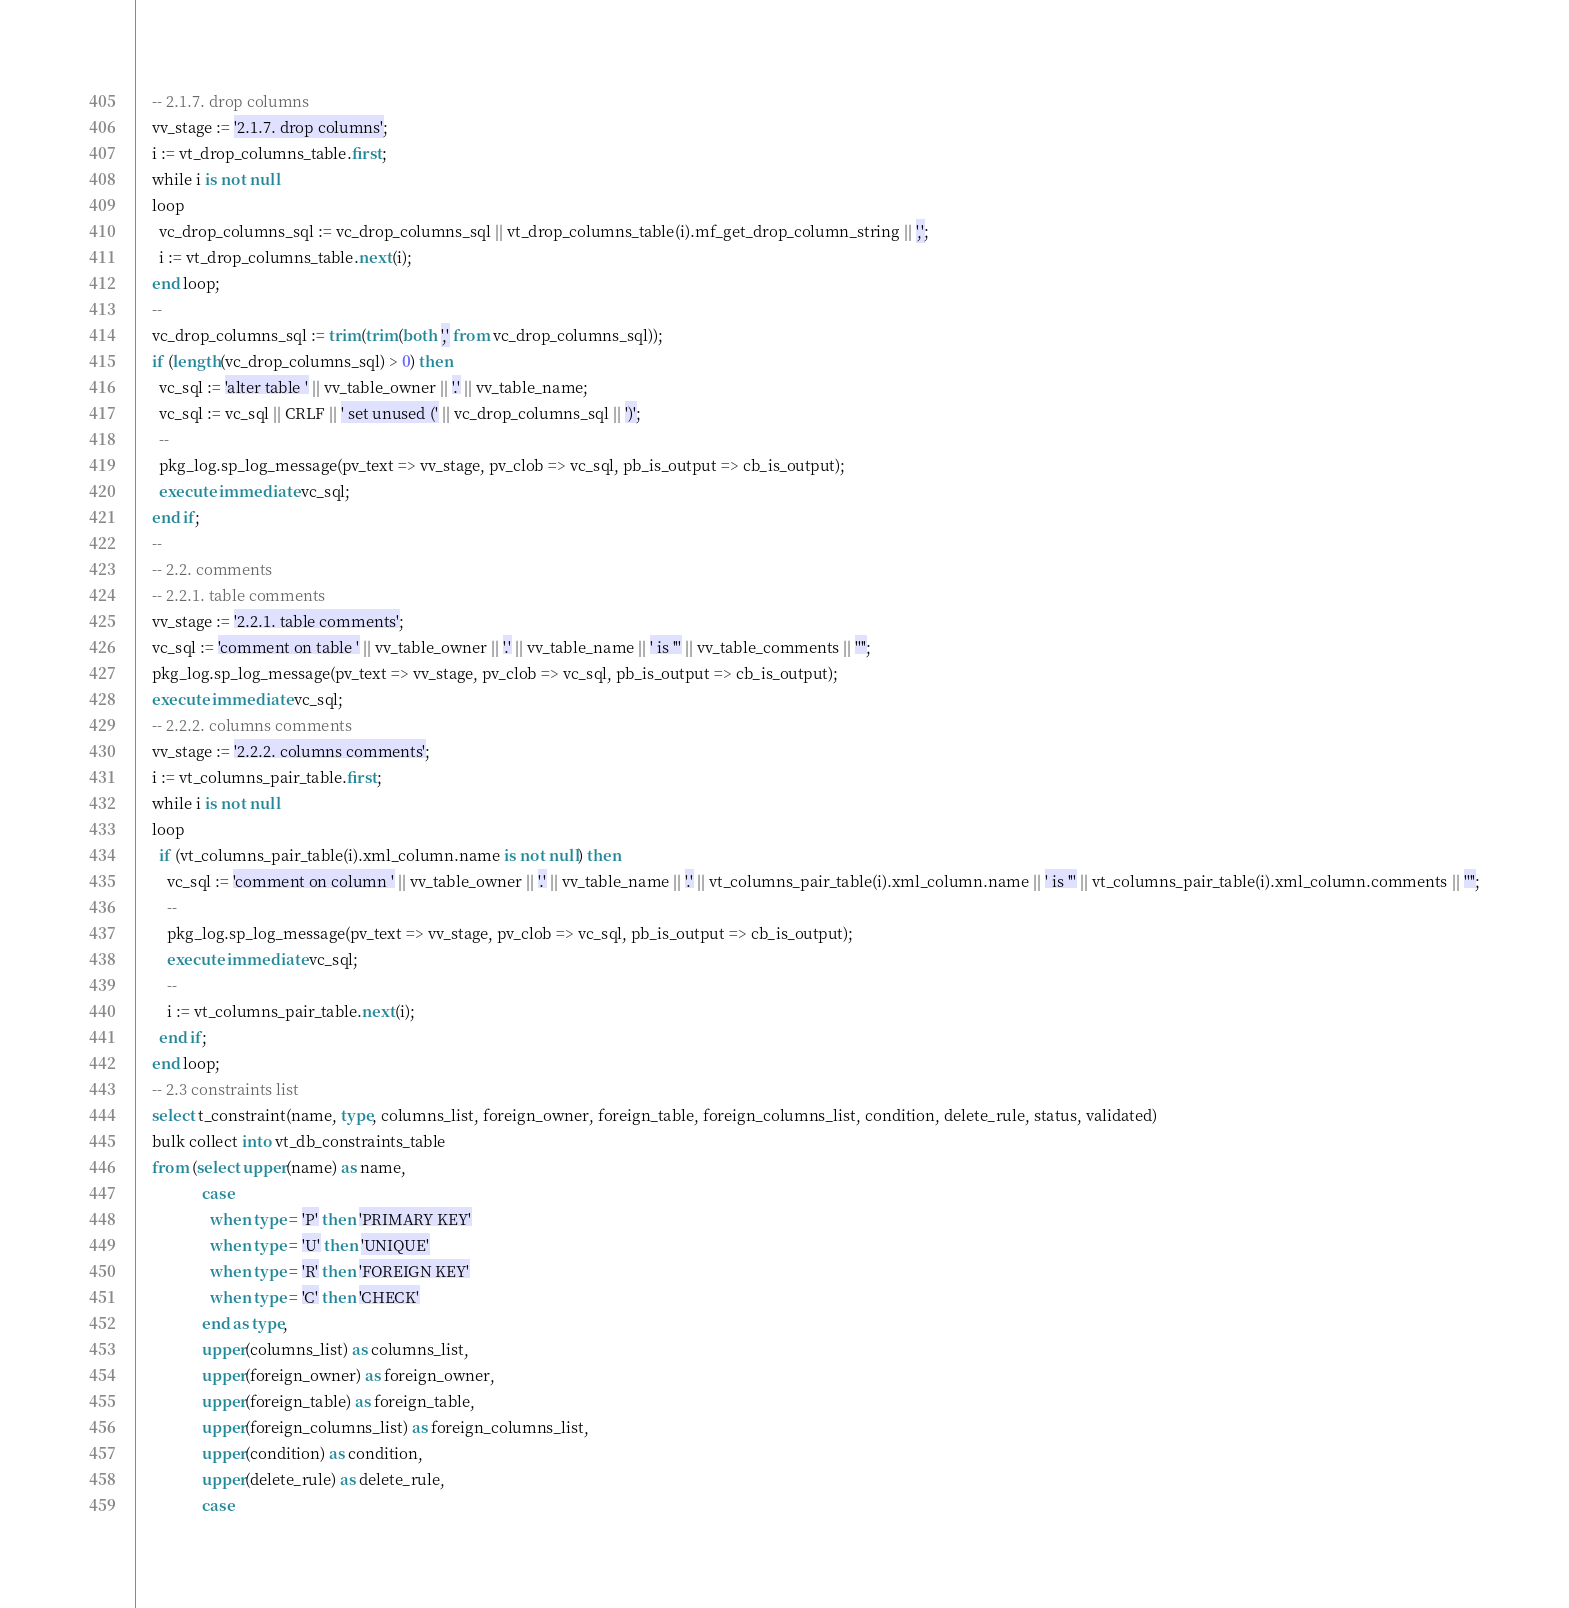Convert code to text. <code><loc_0><loc_0><loc_500><loc_500><_SQL_>    -- 2.1.7. drop columns
    vv_stage := '2.1.7. drop columns';
    i := vt_drop_columns_table.first;
    while i is not null
    loop
      vc_drop_columns_sql := vc_drop_columns_sql || vt_drop_columns_table(i).mf_get_drop_column_string || ',';
      i := vt_drop_columns_table.next(i);
    end loop;
    --
    vc_drop_columns_sql := trim(trim(both ',' from vc_drop_columns_sql));
    if (length(vc_drop_columns_sql) > 0) then
      vc_sql := 'alter table ' || vv_table_owner || '.' || vv_table_name;
      vc_sql := vc_sql || CRLF || ' set unused (' || vc_drop_columns_sql || ')';
      --
      pkg_log.sp_log_message(pv_text => vv_stage, pv_clob => vc_sql, pb_is_output => cb_is_output);
      execute immediate vc_sql;
    end if;
    --
    -- 2.2. comments
    -- 2.2.1. table comments
    vv_stage := '2.2.1. table comments';
    vc_sql := 'comment on table ' || vv_table_owner || '.' || vv_table_name || ' is ''' || vv_table_comments || '''';
    pkg_log.sp_log_message(pv_text => vv_stage, pv_clob => vc_sql, pb_is_output => cb_is_output);
    execute immediate vc_sql;
    -- 2.2.2. columns comments
    vv_stage := '2.2.2. columns comments';
    i := vt_columns_pair_table.first;
    while i is not null
    loop
      if (vt_columns_pair_table(i).xml_column.name is not null) then
        vc_sql := 'comment on column ' || vv_table_owner || '.' || vv_table_name || '.' || vt_columns_pair_table(i).xml_column.name || ' is ''' || vt_columns_pair_table(i).xml_column.comments || '''';
        --
        pkg_log.sp_log_message(pv_text => vv_stage, pv_clob => vc_sql, pb_is_output => cb_is_output);
        execute immediate vc_sql;
        --
        i := vt_columns_pair_table.next(i);
      end if;
    end loop;
    -- 2.3 constraints list
    select t_constraint(name, type, columns_list, foreign_owner, foreign_table, foreign_columns_list, condition, delete_rule, status, validated)
    bulk collect into vt_db_constraints_table
    from (select upper(name) as name,
                 case
                   when type = 'P' then 'PRIMARY KEY'
                   when type = 'U' then 'UNIQUE'
                   when type = 'R' then 'FOREIGN KEY'
                   when type = 'C' then 'CHECK'
                 end as type,
                 upper(columns_list) as columns_list,
                 upper(foreign_owner) as foreign_owner,
                 upper(foreign_table) as foreign_table,
                 upper(foreign_columns_list) as foreign_columns_list,
                 upper(condition) as condition,
                 upper(delete_rule) as delete_rule,
                 case</code> 